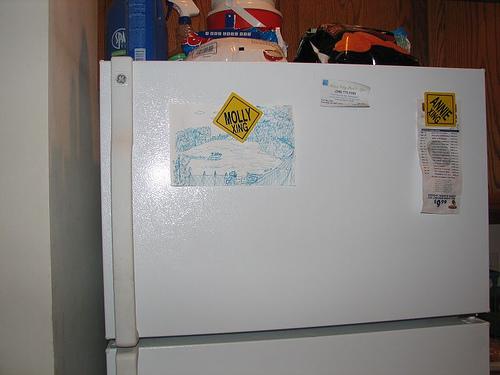What is on the fridge?
Keep it brief. Magnets. What is on top of the refrigerator?
Be succinct. Appliances. What color is the freezer?
Write a very short answer. White. Whose house is this?
Concise answer only. Molly and annie. What is in the house present?
Short answer required. Fridge. How many magnets are on the refrigerator?
Be succinct. 2. What is on the refrigerator?
Answer briefly. Magnets. What color is the fridge?
Short answer required. White. Does the fridge have magnets?
Be succinct. Yes. 